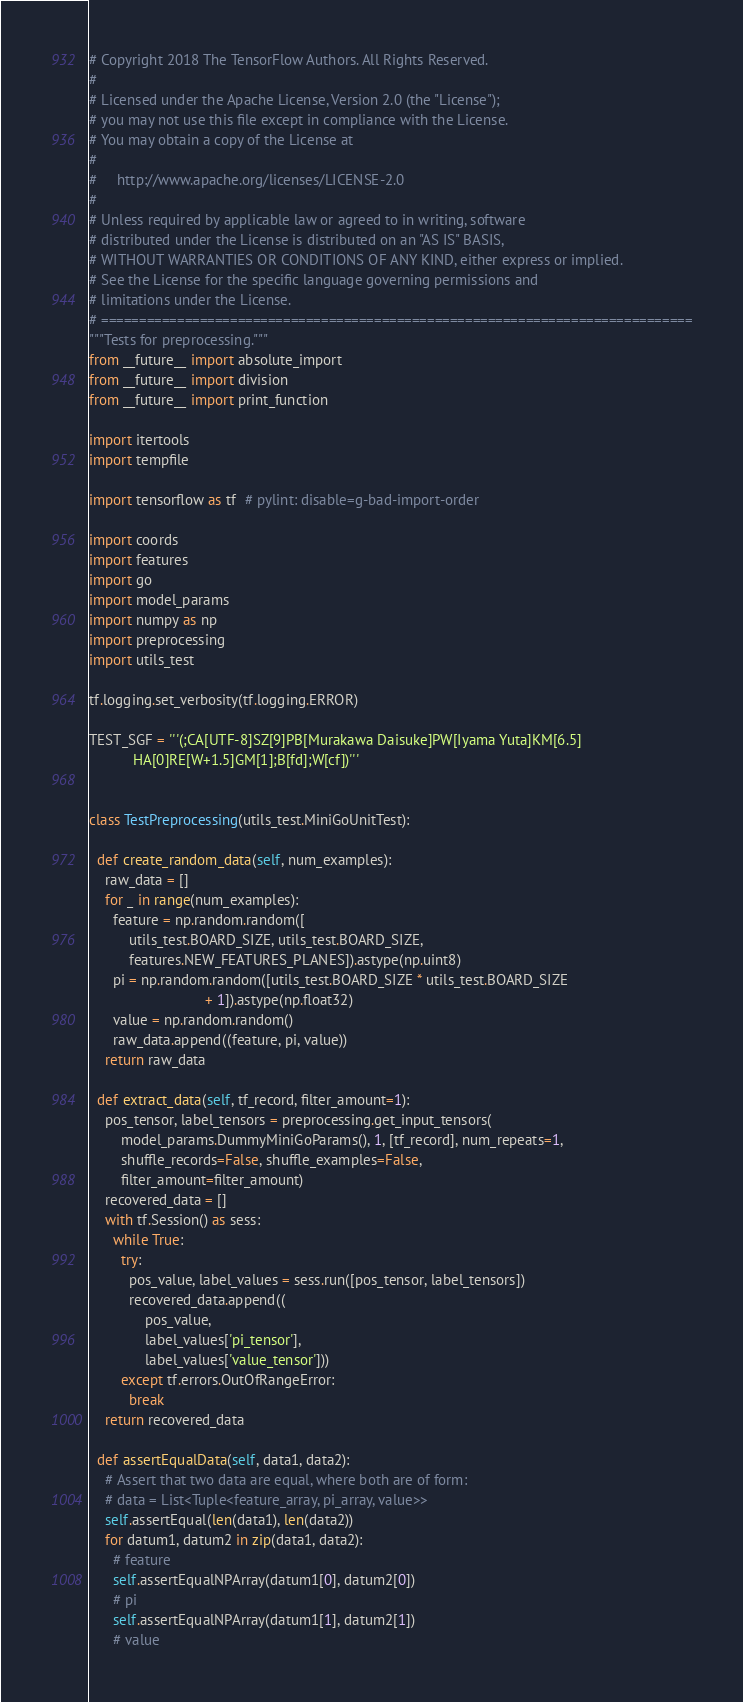<code> <loc_0><loc_0><loc_500><loc_500><_Python_># Copyright 2018 The TensorFlow Authors. All Rights Reserved.
#
# Licensed under the Apache License, Version 2.0 (the "License");
# you may not use this file except in compliance with the License.
# You may obtain a copy of the License at
#
#     http://www.apache.org/licenses/LICENSE-2.0
#
# Unless required by applicable law or agreed to in writing, software
# distributed under the License is distributed on an "AS IS" BASIS,
# WITHOUT WARRANTIES OR CONDITIONS OF ANY KIND, either express or implied.
# See the License for the specific language governing permissions and
# limitations under the License.
# ==============================================================================
"""Tests for preprocessing."""
from __future__ import absolute_import
from __future__ import division
from __future__ import print_function

import itertools
import tempfile

import tensorflow as tf  # pylint: disable=g-bad-import-order

import coords
import features
import go
import model_params
import numpy as np
import preprocessing
import utils_test

tf.logging.set_verbosity(tf.logging.ERROR)

TEST_SGF = '''(;CA[UTF-8]SZ[9]PB[Murakawa Daisuke]PW[Iyama Yuta]KM[6.5]
           HA[0]RE[W+1.5]GM[1];B[fd];W[cf])'''


class TestPreprocessing(utils_test.MiniGoUnitTest):

  def create_random_data(self, num_examples):
    raw_data = []
    for _ in range(num_examples):
      feature = np.random.random([
          utils_test.BOARD_SIZE, utils_test.BOARD_SIZE,
          features.NEW_FEATURES_PLANES]).astype(np.uint8)
      pi = np.random.random([utils_test.BOARD_SIZE * utils_test.BOARD_SIZE
                             + 1]).astype(np.float32)
      value = np.random.random()
      raw_data.append((feature, pi, value))
    return raw_data

  def extract_data(self, tf_record, filter_amount=1):
    pos_tensor, label_tensors = preprocessing.get_input_tensors(
        model_params.DummyMiniGoParams(), 1, [tf_record], num_repeats=1,
        shuffle_records=False, shuffle_examples=False,
        filter_amount=filter_amount)
    recovered_data = []
    with tf.Session() as sess:
      while True:
        try:
          pos_value, label_values = sess.run([pos_tensor, label_tensors])
          recovered_data.append((
              pos_value,
              label_values['pi_tensor'],
              label_values['value_tensor']))
        except tf.errors.OutOfRangeError:
          break
    return recovered_data

  def assertEqualData(self, data1, data2):
    # Assert that two data are equal, where both are of form:
    # data = List<Tuple<feature_array, pi_array, value>>
    self.assertEqual(len(data1), len(data2))
    for datum1, datum2 in zip(data1, data2):
      # feature
      self.assertEqualNPArray(datum1[0], datum2[0])
      # pi
      self.assertEqualNPArray(datum1[1], datum2[1])
      # value</code> 